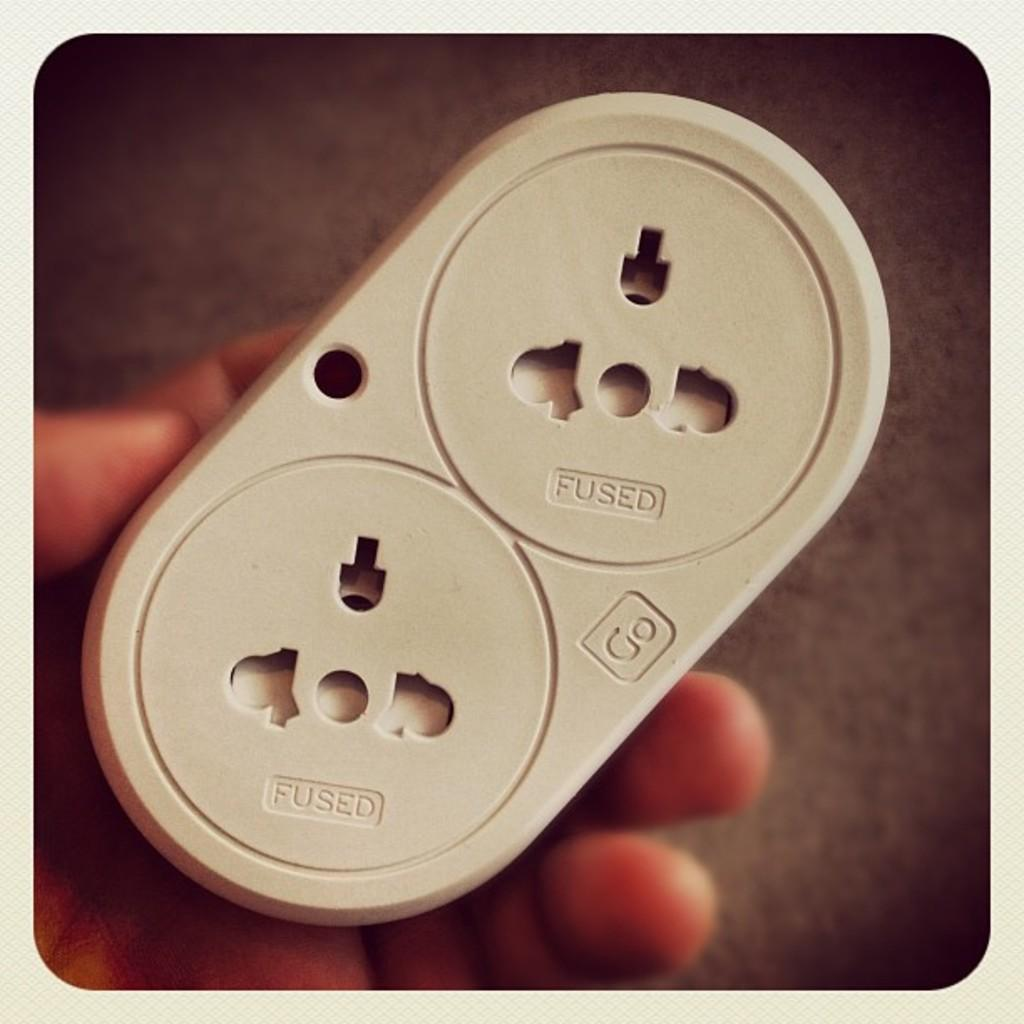<image>
Render a clear and concise summary of the photo. An outlet adapter with the words Fused and Go on it. 